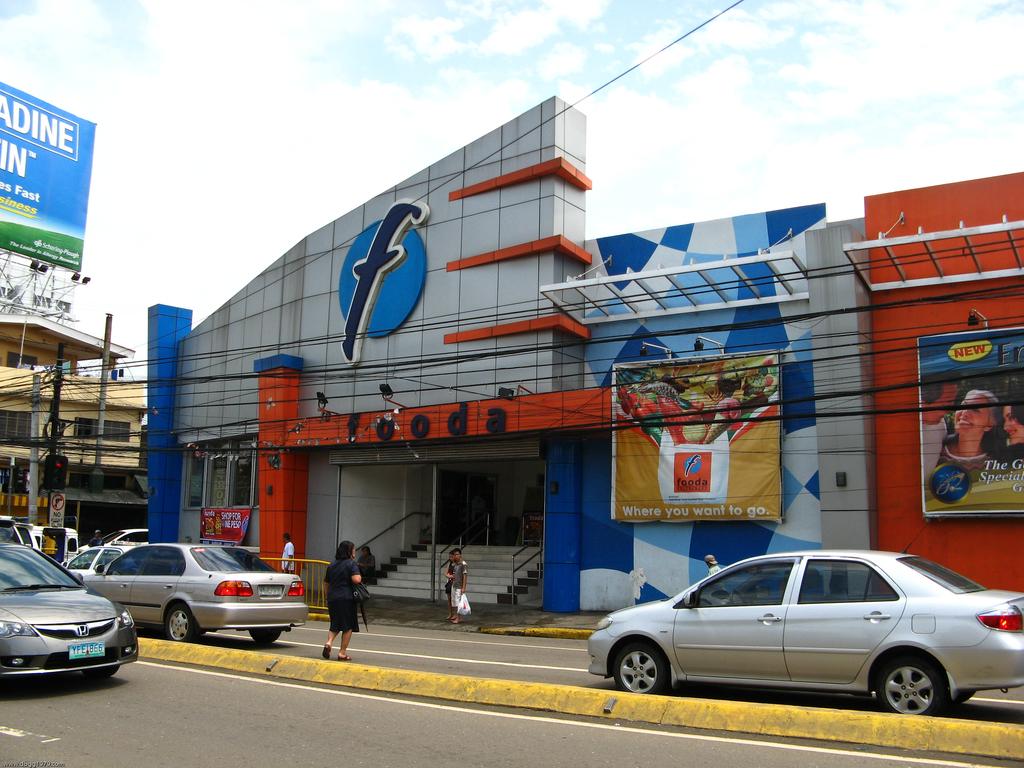What is the name of this store?
Ensure brevity in your answer.  Fooda. 